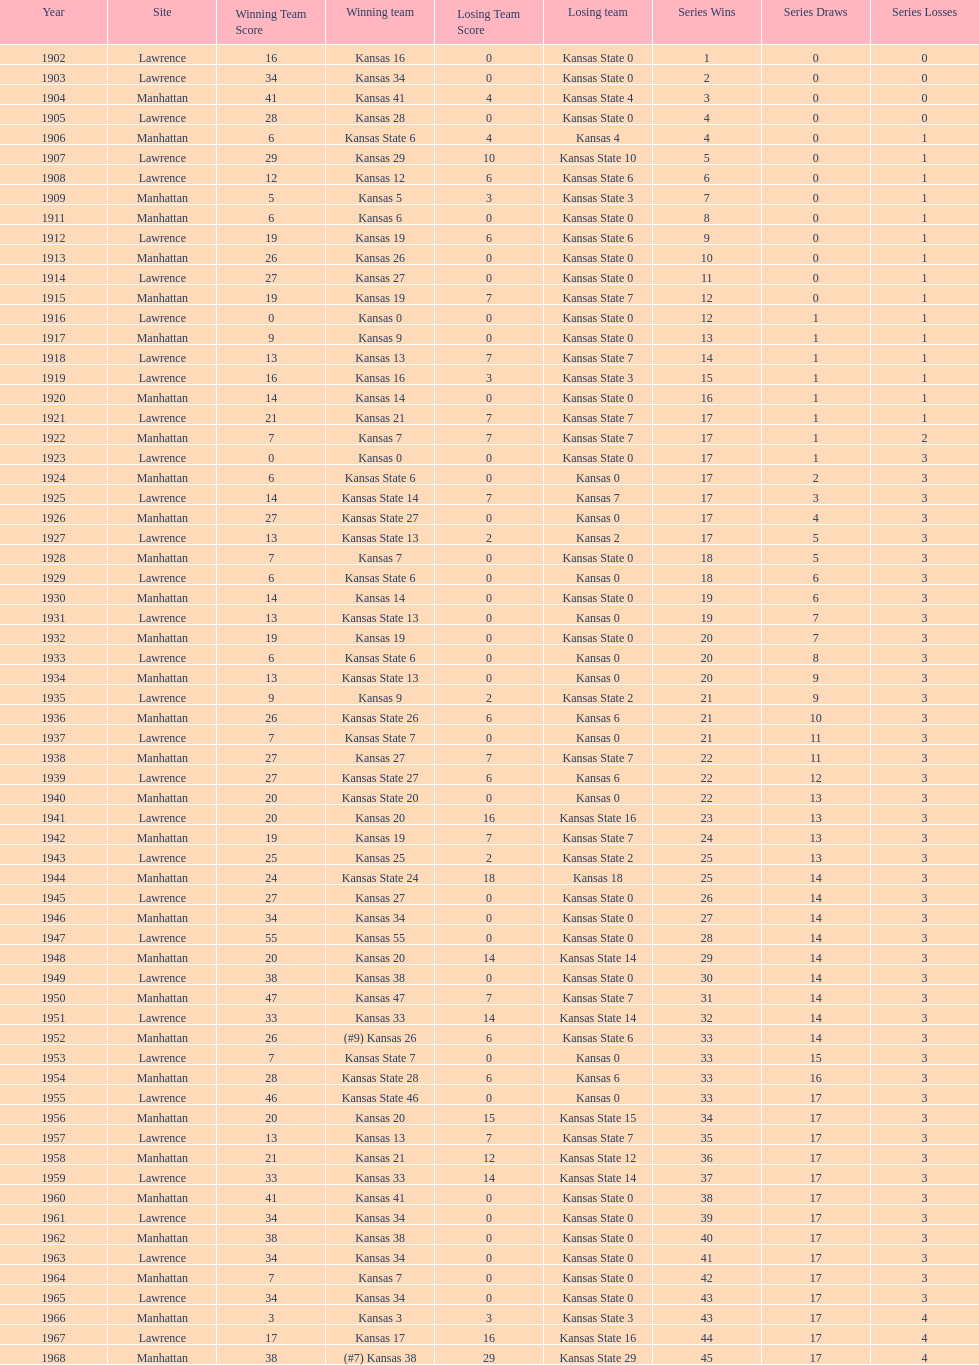When was the last time kansas state lost with 0 points in manhattan? 1964. 